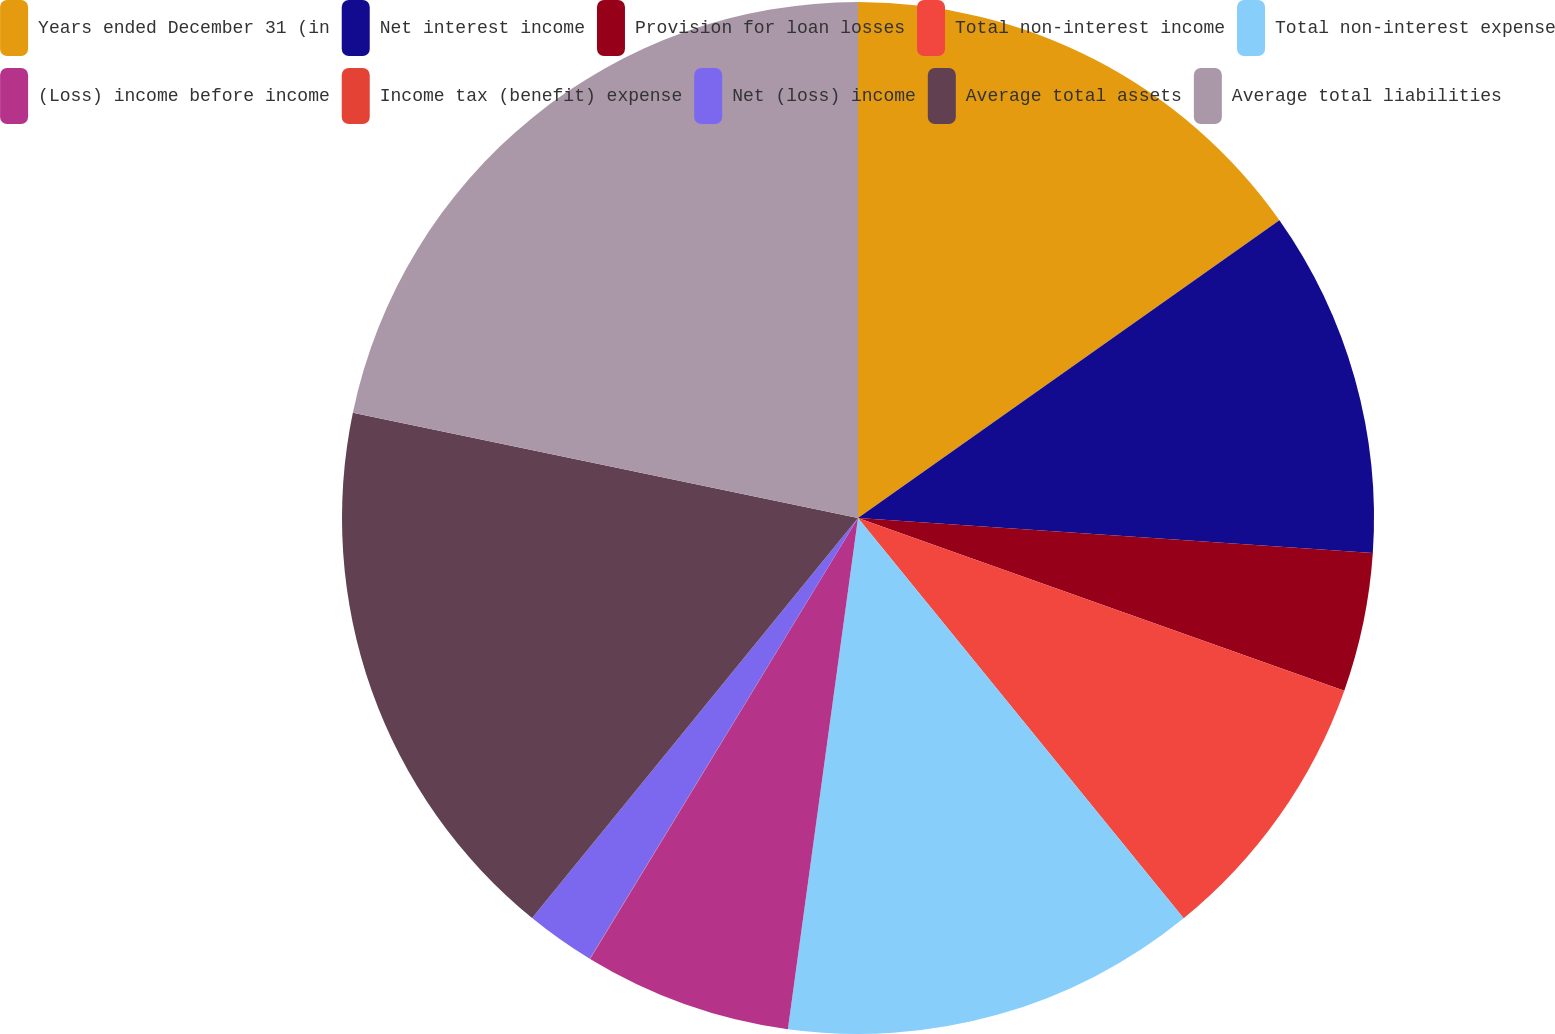Convert chart to OTSL. <chart><loc_0><loc_0><loc_500><loc_500><pie_chart><fcel>Years ended December 31 (in<fcel>Net interest income<fcel>Provision for loan losses<fcel>Total non-interest income<fcel>Total non-interest expense<fcel>(Loss) income before income<fcel>Income tax (benefit) expense<fcel>Net (loss) income<fcel>Average total assets<fcel>Average total liabilities<nl><fcel>15.21%<fcel>10.87%<fcel>4.35%<fcel>8.7%<fcel>13.04%<fcel>6.52%<fcel>0.01%<fcel>2.18%<fcel>17.39%<fcel>21.73%<nl></chart> 